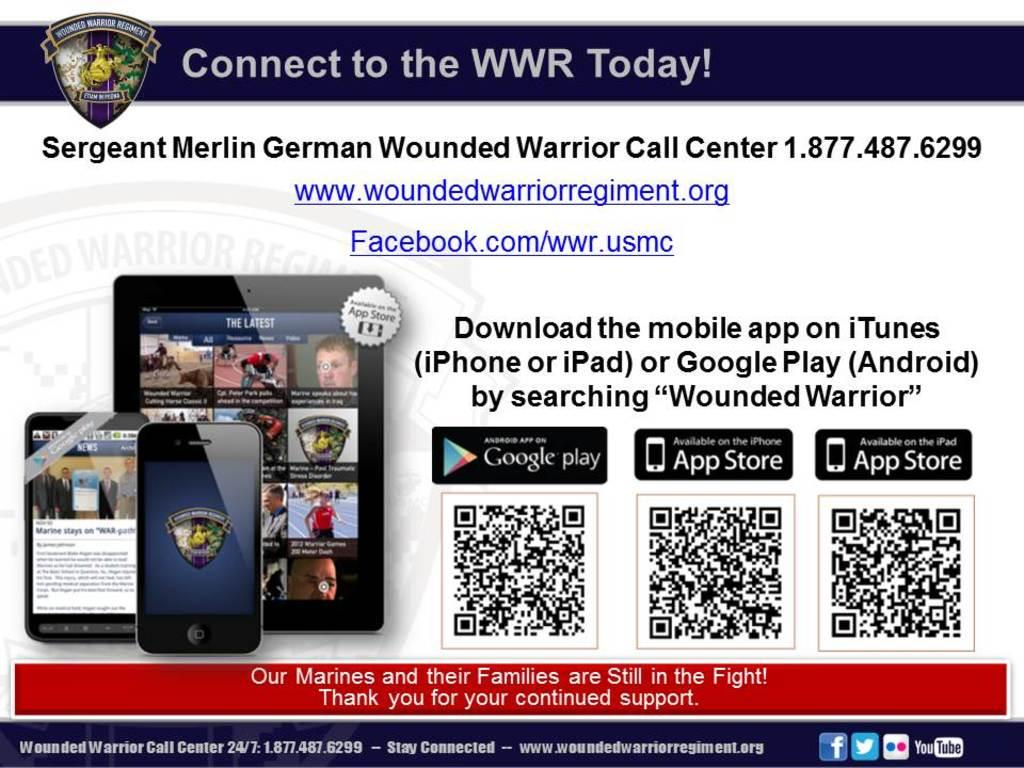<image>
Offer a succinct explanation of the picture presented. An advertisement is for the Wounded Warrior's and includes contact information. 